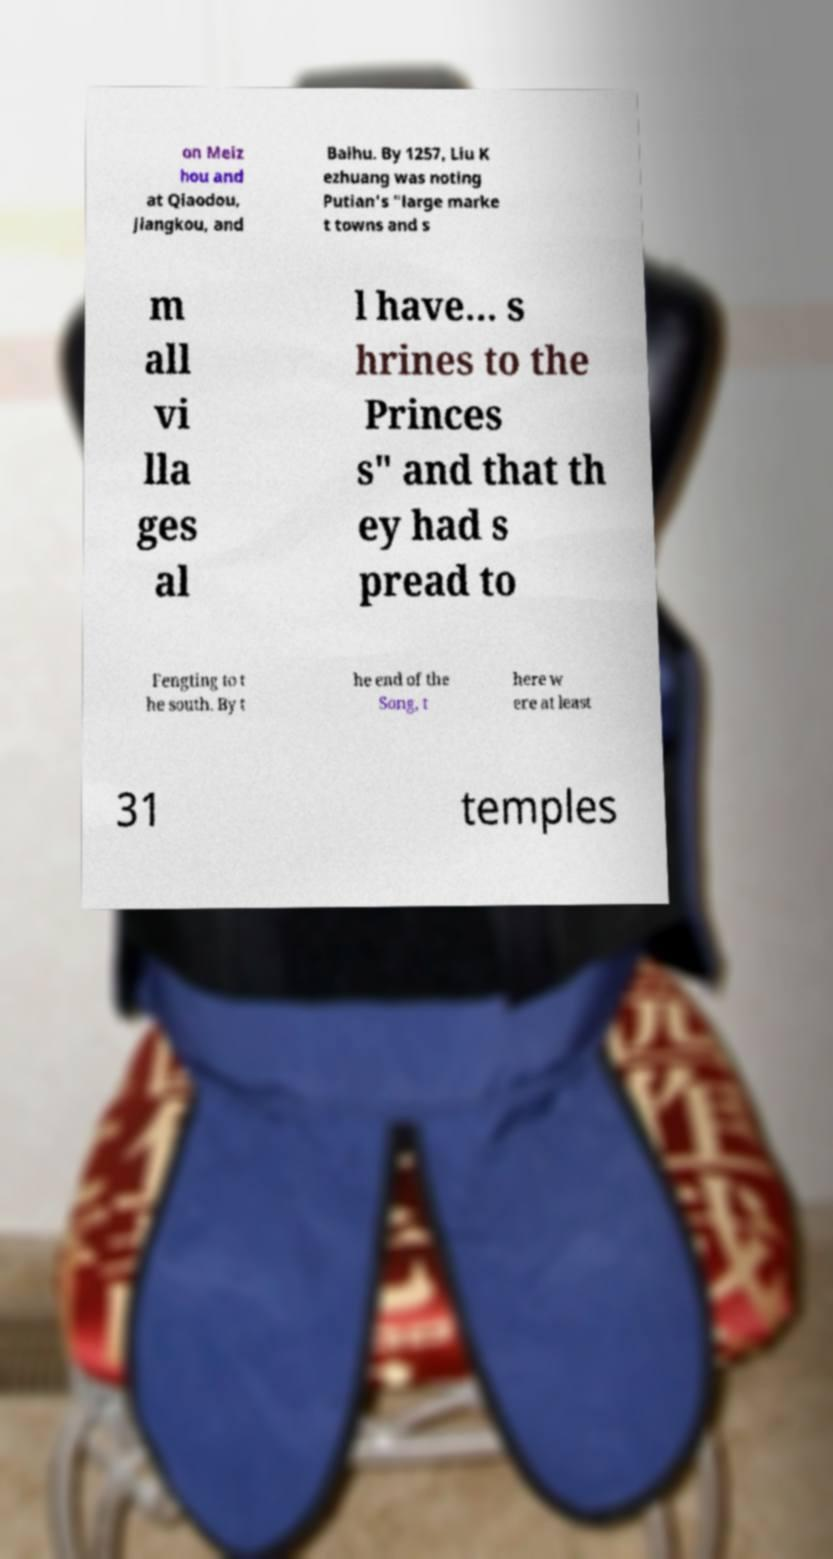For documentation purposes, I need the text within this image transcribed. Could you provide that? on Meiz hou and at Qiaodou, Jiangkou, and Baihu. By 1257, Liu K ezhuang was noting Putian's "large marke t towns and s m all vi lla ges al l have... s hrines to the Princes s" and that th ey had s pread to Fengting to t he south. By t he end of the Song, t here w ere at least 31 temples 